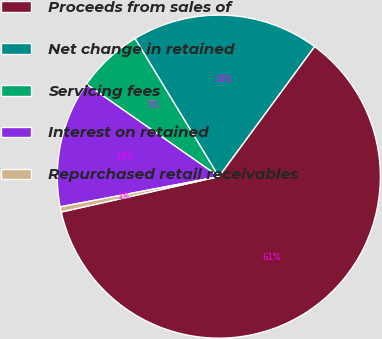<chart> <loc_0><loc_0><loc_500><loc_500><pie_chart><fcel>Proceeds from sales of<fcel>Net change in retained<fcel>Servicing fees<fcel>Interest on retained<fcel>Repurchased retail receivables<nl><fcel>61.39%<fcel>18.78%<fcel>6.61%<fcel>12.7%<fcel>0.52%<nl></chart> 